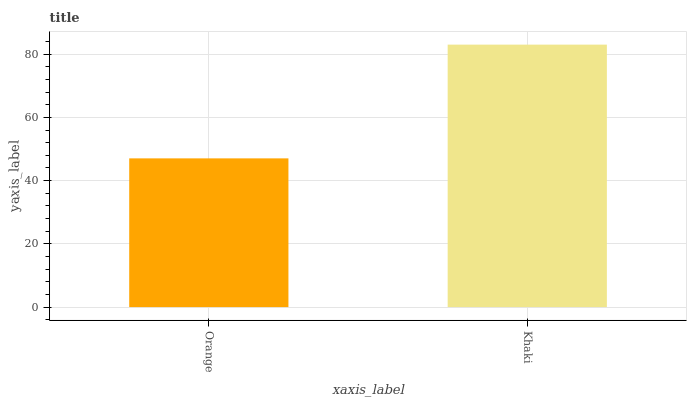Is Khaki the minimum?
Answer yes or no. No. Is Khaki greater than Orange?
Answer yes or no. Yes. Is Orange less than Khaki?
Answer yes or no. Yes. Is Orange greater than Khaki?
Answer yes or no. No. Is Khaki less than Orange?
Answer yes or no. No. Is Khaki the high median?
Answer yes or no. Yes. Is Orange the low median?
Answer yes or no. Yes. Is Orange the high median?
Answer yes or no. No. Is Khaki the low median?
Answer yes or no. No. 